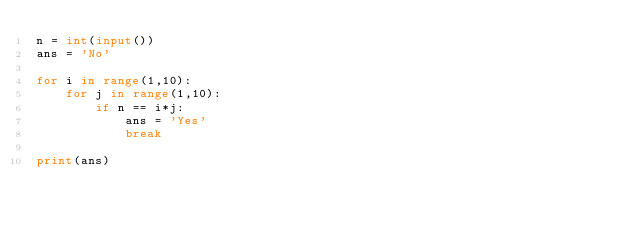Convert code to text. <code><loc_0><loc_0><loc_500><loc_500><_Python_>n = int(input())
ans = 'No'

for i in range(1,10):
    for j in range(1,10):
        if n == i*j:
            ans = 'Yes'
            break
    
print(ans)
</code> 